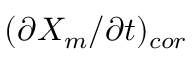<formula> <loc_0><loc_0><loc_500><loc_500>( \partial X _ { m } / \partial t ) _ { c o r }</formula> 